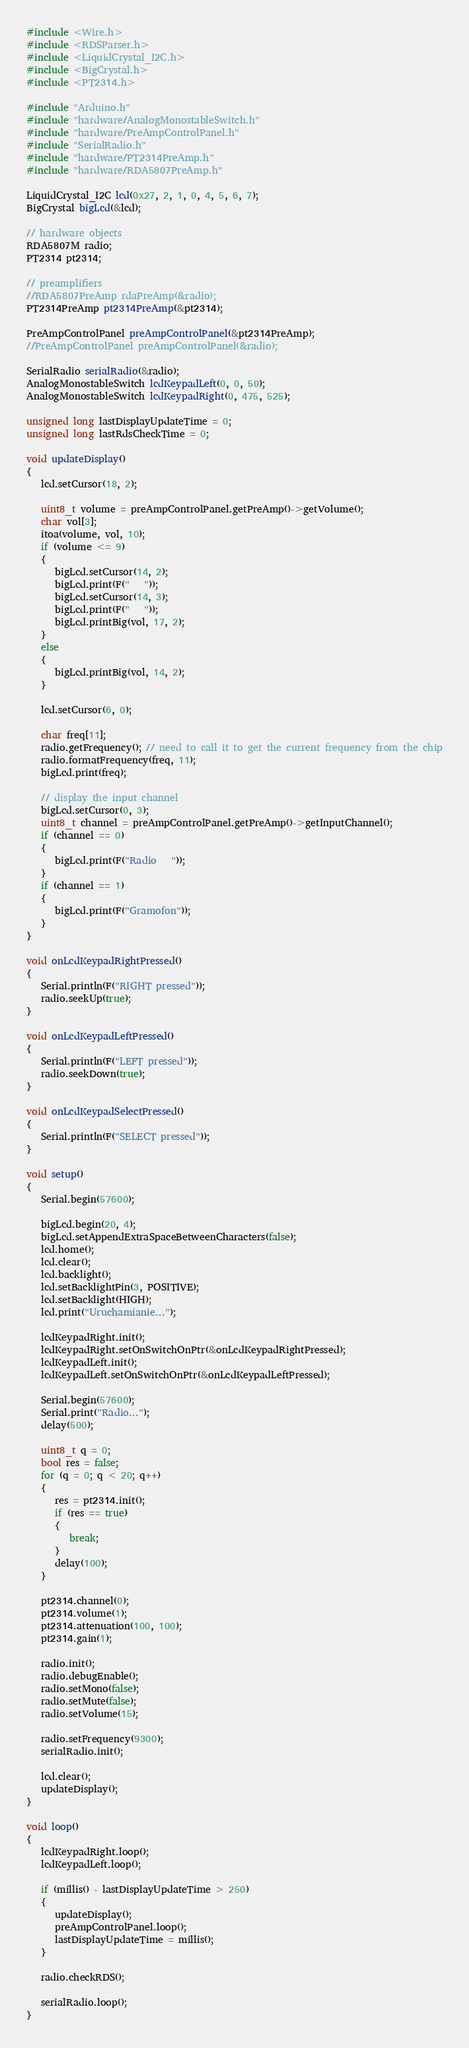<code> <loc_0><loc_0><loc_500><loc_500><_C++_>#include <Wire.h>
#include <RDSParser.h>
#include <LiquidCrystal_I2C.h>
#include <BigCrystal.h>
#include <PT2314.h>

#include "Arduino.h"
#include "hardware/AnalogMonostableSwitch.h"
#include "hardware/PreAmpControlPanel.h"
#include "SerialRadio.h"
#include "hardware/PT2314PreAmp.h"
#include "hardware/RDA5807PreAmp.h"

LiquidCrystal_I2C lcd(0x27, 2, 1, 0, 4, 5, 6, 7);
BigCrystal bigLcd(&lcd);

// hardware objects
RDA5807M radio;
PT2314 pt2314;

// preamplifiers
//RDA5807PreAmp rdaPreAmp(&radio);
PT2314PreAmp pt2314PreAmp(&pt2314);

PreAmpControlPanel preAmpControlPanel(&pt2314PreAmp);
//PreAmpControlPanel preAmpControlPanel(&radio);

SerialRadio serialRadio(&radio);
AnalogMonostableSwitch lcdKeypadLeft(0, 0, 50);
AnalogMonostableSwitch lcdKeypadRight(0, 475, 525);

unsigned long lastDisplayUpdateTime = 0;
unsigned long lastRdsCheckTime = 0;

void updateDisplay()
{
   lcd.setCursor(18, 2);

   uint8_t volume = preAmpControlPanel.getPreAmp()->getVolume();
   char vol[3];
   itoa(volume, vol, 10);
   if (volume <= 9)
   {
      bigLcd.setCursor(14, 2);
      bigLcd.print(F("   "));
      bigLcd.setCursor(14, 3);
      bigLcd.print(F("   "));
      bigLcd.printBig(vol, 17, 2);
   }
   else
   {
      bigLcd.printBig(vol, 14, 2);
   }

   lcd.setCursor(6, 0);

   char freq[11];
   radio.getFrequency(); // need to call it to get the current frequency from the chip
   radio.formatFrequency(freq, 11);
   bigLcd.print(freq);

   // display the input channel
   bigLcd.setCursor(0, 3);
   uint8_t channel = preAmpControlPanel.getPreAmp()->getInputChannel();
   if (channel == 0)
   {
      bigLcd.print(F("Radio   "));
   }
   if (channel == 1)
   {
      bigLcd.print(F("Gramofon"));
   }
}

void onLcdKeypadRightPressed()
{
   Serial.println(F("RIGHT pressed"));
   radio.seekUp(true);
}

void onLcdKeypadLeftPressed()
{
   Serial.println(F("LEFT pressed"));
   radio.seekDown(true);
}

void onLcdKeypadSelectPressed()
{
   Serial.println(F("SELECT pressed"));
}

void setup()
{
   Serial.begin(57600);

   bigLcd.begin(20, 4);
   bigLcd.setAppendExtraSpaceBetweenCharacters(false);
   lcd.home();
   lcd.clear();
   lcd.backlight();
   lcd.setBacklightPin(3, POSITIVE);
   lcd.setBacklight(HIGH);
   lcd.print("Uruchamianie...");

   lcdKeypadRight.init();
   lcdKeypadRight.setOnSwitchOnPtr(&onLcdKeypadRightPressed);
   lcdKeypadLeft.init();
   lcdKeypadLeft.setOnSwitchOnPtr(&onLcdKeypadLeftPressed);

   Serial.begin(57600);
   Serial.print("Radio...");
   delay(500);

   uint8_t q = 0;
   bool res = false;
   for (q = 0; q < 20; q++)
   {
      res = pt2314.init();
      if (res == true)
      {
         break;
      }
      delay(100);
   }

   pt2314.channel(0);
   pt2314.volume(1);
   pt2314.attenuation(100, 100);
   pt2314.gain(1);

   radio.init();
   radio.debugEnable();
   radio.setMono(false);
   radio.setMute(false);
   radio.setVolume(15);

   radio.setFrequency(9300);
   serialRadio.init();

   lcd.clear();
   updateDisplay();
}

void loop()
{
   lcdKeypadRight.loop();
   lcdKeypadLeft.loop();

   if (millis() - lastDisplayUpdateTime > 250)
   {
      updateDisplay();
      preAmpControlPanel.loop();
      lastDisplayUpdateTime = millis();
   }

   radio.checkRDS();

   serialRadio.loop();
}
</code> 